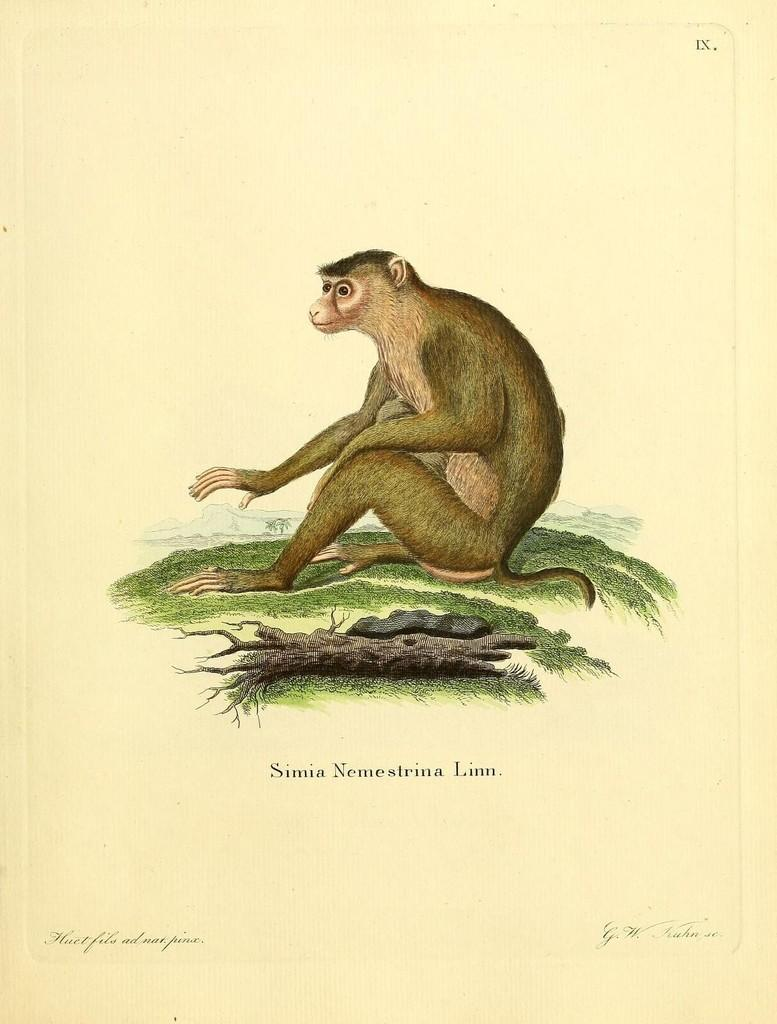What is featured in the image in the form of a printed material? There is a poster in the image. What is depicted on the poster? The poster contains an image of an animal on the grass. What other object is included in the poster? The poster includes a wooden object. Are there any words on the poster? Yes, the poster has text on it. What type of scent can be detected from the poster in the image? There is no scent associated with the poster in the image, as it is a printed material and does not emit any fragrance. 